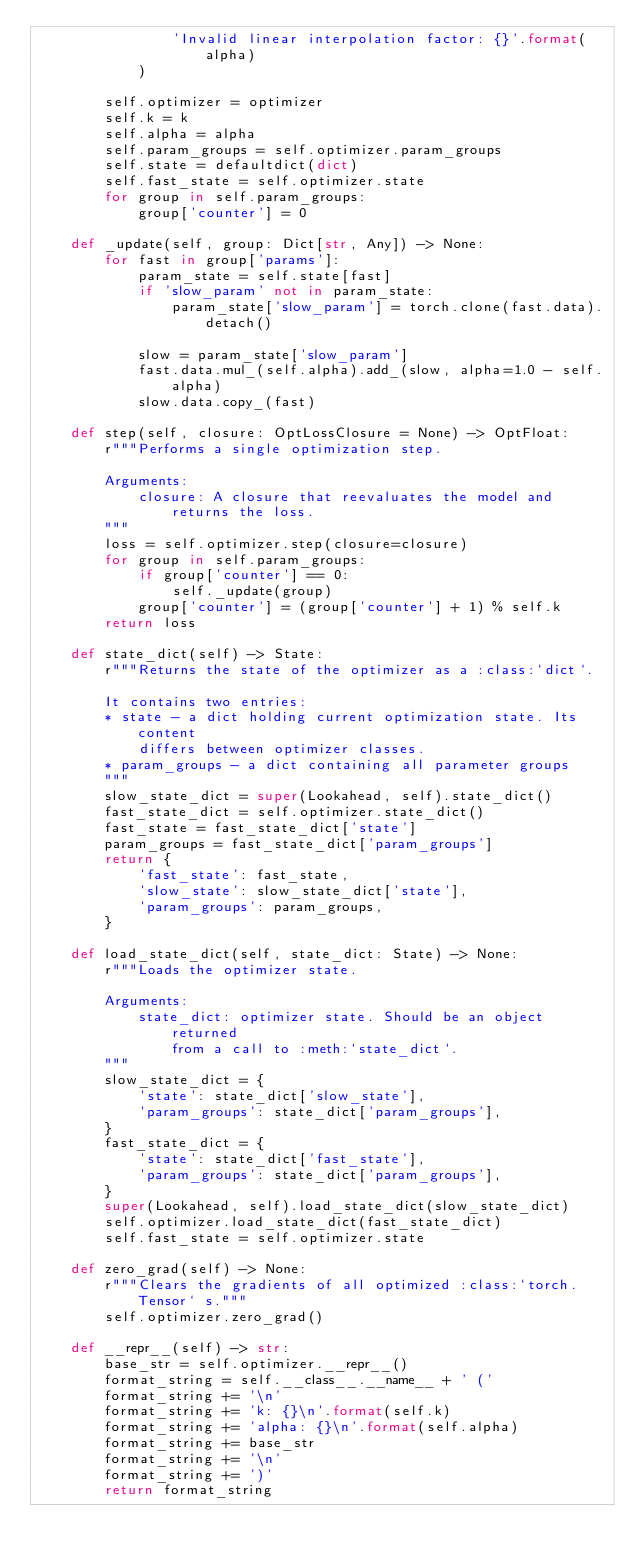<code> <loc_0><loc_0><loc_500><loc_500><_Python_>                'Invalid linear interpolation factor: {}'.format(alpha)
            )

        self.optimizer = optimizer
        self.k = k
        self.alpha = alpha
        self.param_groups = self.optimizer.param_groups
        self.state = defaultdict(dict)
        self.fast_state = self.optimizer.state
        for group in self.param_groups:
            group['counter'] = 0

    def _update(self, group: Dict[str, Any]) -> None:
        for fast in group['params']:
            param_state = self.state[fast]
            if 'slow_param' not in param_state:
                param_state['slow_param'] = torch.clone(fast.data).detach()

            slow = param_state['slow_param']
            fast.data.mul_(self.alpha).add_(slow, alpha=1.0 - self.alpha)
            slow.data.copy_(fast)

    def step(self, closure: OptLossClosure = None) -> OptFloat:
        r"""Performs a single optimization step.

        Arguments:
            closure: A closure that reevaluates the model and returns the loss.
        """
        loss = self.optimizer.step(closure=closure)
        for group in self.param_groups:
            if group['counter'] == 0:
                self._update(group)
            group['counter'] = (group['counter'] + 1) % self.k
        return loss

    def state_dict(self) -> State:
        r"""Returns the state of the optimizer as a :class:`dict`.

        It contains two entries:
        * state - a dict holding current optimization state. Its content
            differs between optimizer classes.
        * param_groups - a dict containing all parameter groups
        """
        slow_state_dict = super(Lookahead, self).state_dict()
        fast_state_dict = self.optimizer.state_dict()
        fast_state = fast_state_dict['state']
        param_groups = fast_state_dict['param_groups']
        return {
            'fast_state': fast_state,
            'slow_state': slow_state_dict['state'],
            'param_groups': param_groups,
        }

    def load_state_dict(self, state_dict: State) -> None:
        r"""Loads the optimizer state.

        Arguments:
            state_dict: optimizer state. Should be an object returned
                from a call to :meth:`state_dict`.
        """
        slow_state_dict = {
            'state': state_dict['slow_state'],
            'param_groups': state_dict['param_groups'],
        }
        fast_state_dict = {
            'state': state_dict['fast_state'],
            'param_groups': state_dict['param_groups'],
        }
        super(Lookahead, self).load_state_dict(slow_state_dict)
        self.optimizer.load_state_dict(fast_state_dict)
        self.fast_state = self.optimizer.state

    def zero_grad(self) -> None:
        r"""Clears the gradients of all optimized :class:`torch.Tensor` s."""
        self.optimizer.zero_grad()

    def __repr__(self) -> str:
        base_str = self.optimizer.__repr__()
        format_string = self.__class__.__name__ + ' ('
        format_string += '\n'
        format_string += 'k: {}\n'.format(self.k)
        format_string += 'alpha: {}\n'.format(self.alpha)
        format_string += base_str
        format_string += '\n'
        format_string += ')'
        return format_string
</code> 